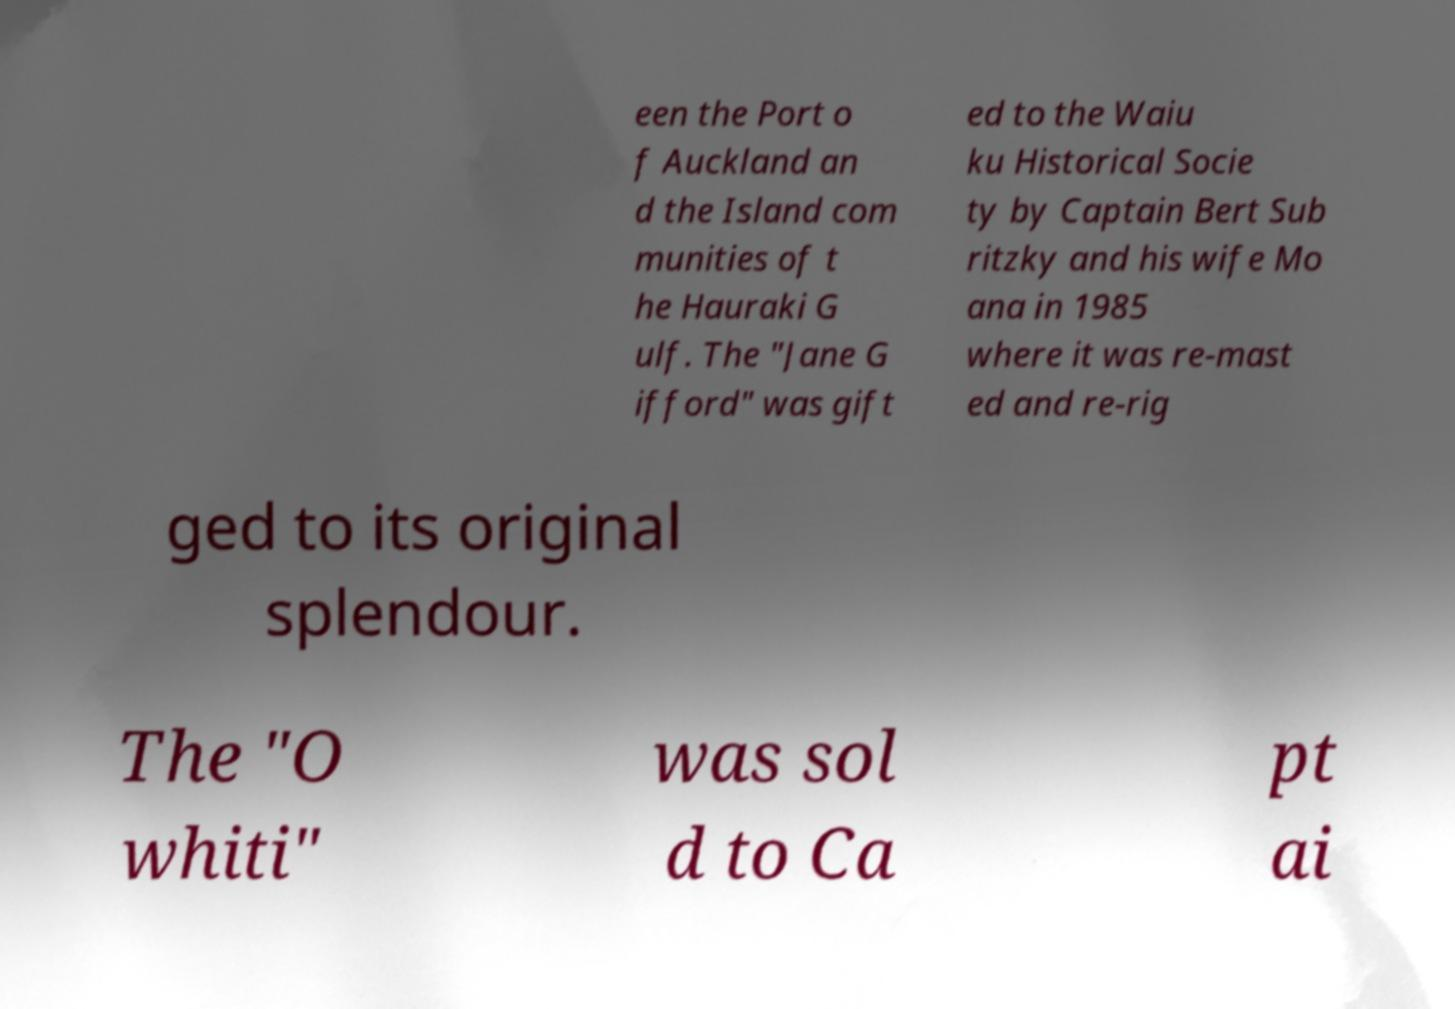I need the written content from this picture converted into text. Can you do that? een the Port o f Auckland an d the Island com munities of t he Hauraki G ulf. The "Jane G ifford" was gift ed to the Waiu ku Historical Socie ty by Captain Bert Sub ritzky and his wife Mo ana in 1985 where it was re-mast ed and re-rig ged to its original splendour. The "O whiti" was sol d to Ca pt ai 